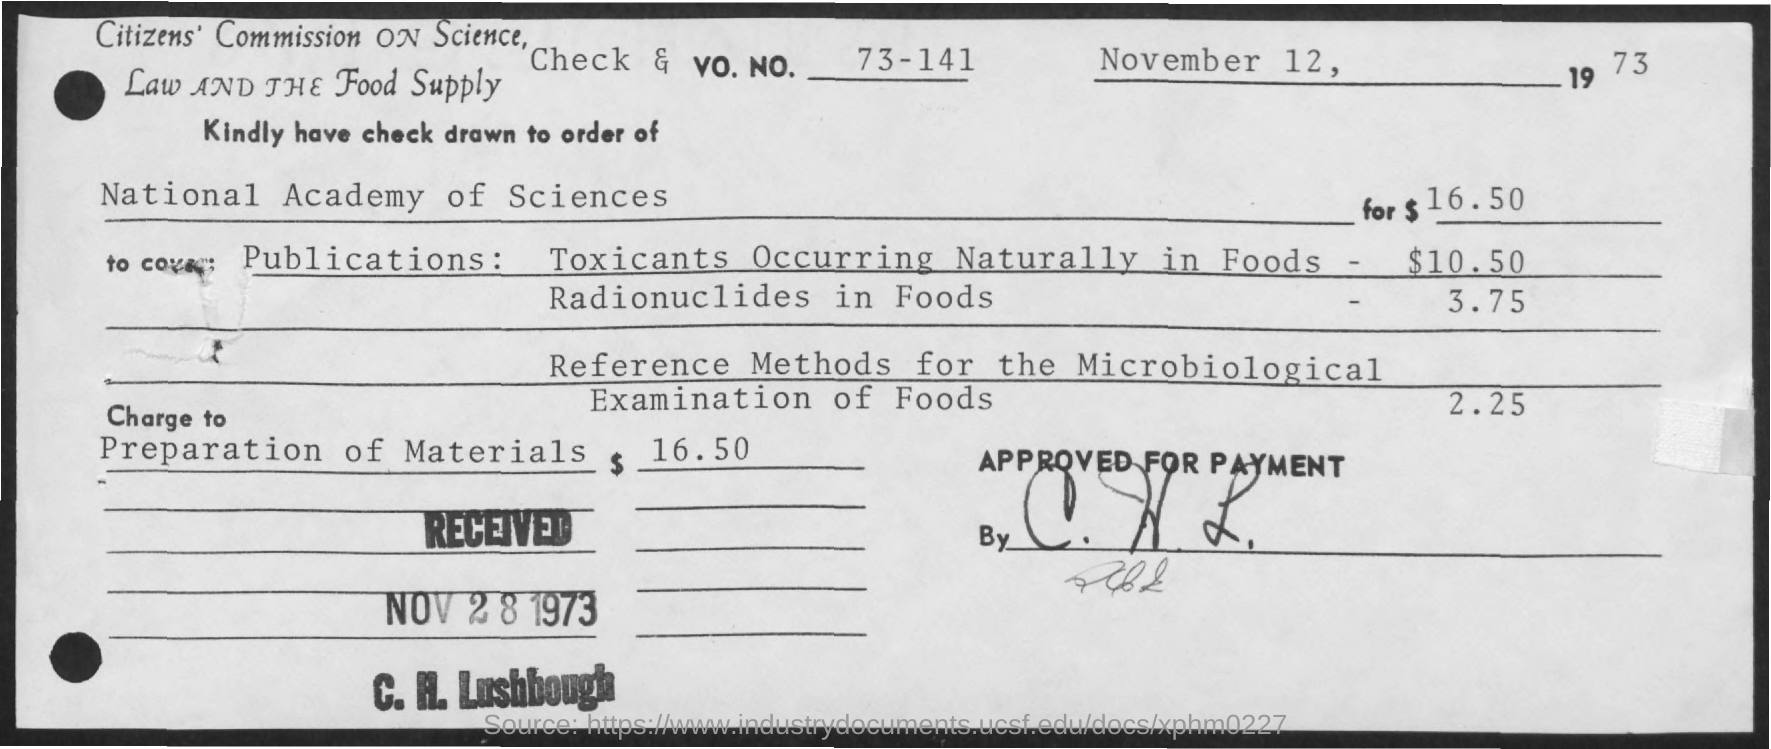Mention a couple of crucial points in this snapshot. The given check is drawn to the order of the National Academy of Sciences, as mentioned in the check's name. The date mentioned on the given page is November 12, 1973. The amount mentioned for the preparation of materials is $16.50. The received date is mentioned as NOV 28 1973. 